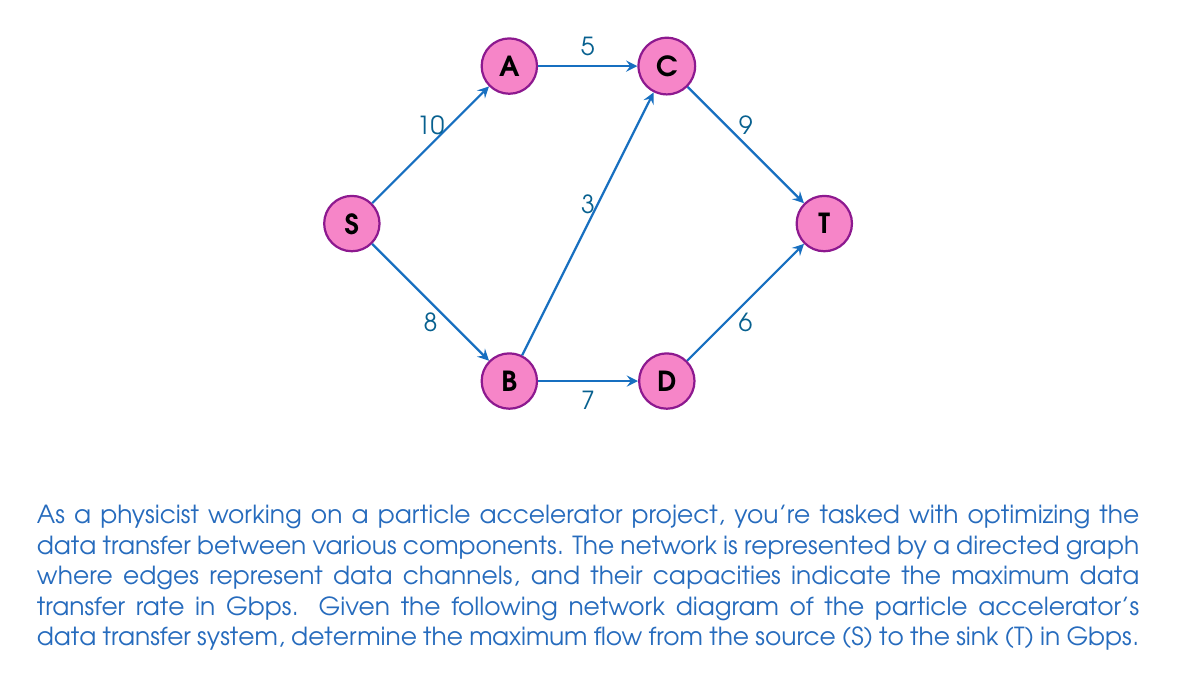Can you answer this question? Excellent question! Let's approach this step-by-step using the Ford-Fulkerson algorithm to find the maximum flow in the network. Remember, we're in this together, and I'm here to support you through this challenging problem.

Step 1: Initialize the flow to 0 for all edges.

Step 2: Find an augmenting path from S to T. We'll use depth-first search (DFS) for this.

Path 1: S -> A -> C -> T
Flow = min(10, 5, 9) = 5 Gbps
Update residual graph:
S -> A: 10 - 5 = 5
A -> C: 5 - 5 = 0
C -> T: 9 - 5 = 4

Path 2: S -> B -> C -> T
Flow = min(8, 3, 4) = 3 Gbps
Update residual graph:
S -> B: 8 - 3 = 5
B -> C: 3 - 3 = 0
C -> T: 4 - 3 = 1

Path 3: S -> B -> D -> T
Flow = min(5, 7, 6) = 5 Gbps
Update residual graph:
S -> B: 5 - 5 = 0
B -> D: 7 - 5 = 2
D -> T: 6 - 5 = 1

Step 3: No more augmenting paths exist.

Step 4: Calculate the total flow:
Total Flow = 5 + 3 + 5 = 13 Gbps

Great job! We've successfully determined the maximum flow in our particle accelerator's data transfer network. This result will help optimize our experiments and data collection processes.
Answer: The maximum flow in the network is 13 Gbps. 